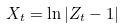Convert formula to latex. <formula><loc_0><loc_0><loc_500><loc_500>X _ { t } = \ln | Z _ { t } - 1 |</formula> 